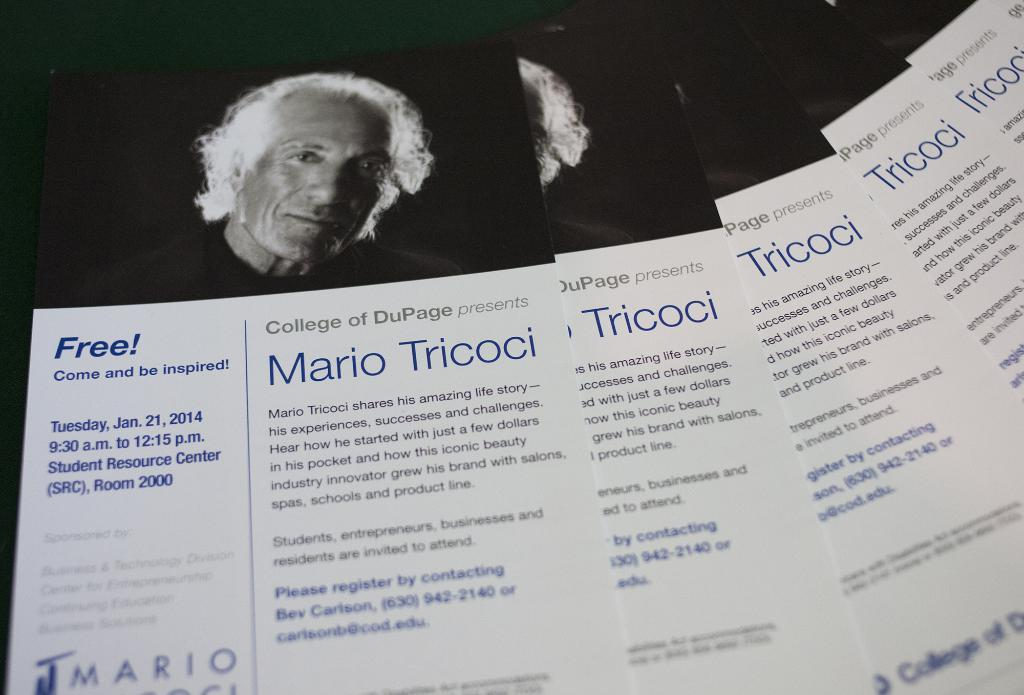What can be seen on the posters in the image? The posters contain pictures of a person. What else is present on the posters besides the pictures? Text is written on the posters. What type of rhythm can be heard coming from the chairs in the image? There are no chairs or sounds of rhythm present in the image. 